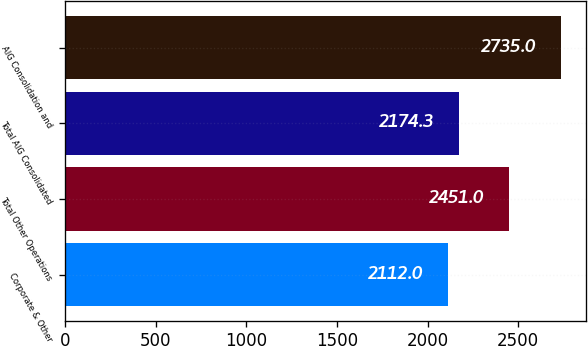Convert chart to OTSL. <chart><loc_0><loc_0><loc_500><loc_500><bar_chart><fcel>Corporate & Other<fcel>Total Other Operations<fcel>Total AIG Consolidated<fcel>AIG Consolidation and<nl><fcel>2112<fcel>2451<fcel>2174.3<fcel>2735<nl></chart> 